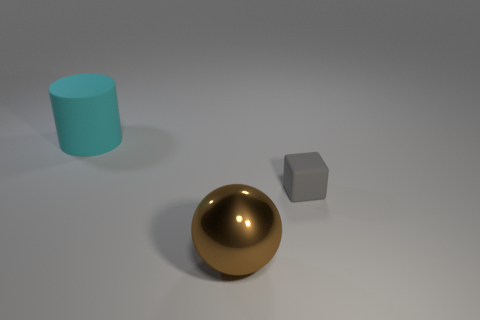There is a large metallic thing; are there any brown objects behind it?
Ensure brevity in your answer.  No. What is the color of the matte object that is behind the matte object that is on the right side of the large object that is in front of the big rubber cylinder?
Your answer should be compact. Cyan. What number of objects are in front of the cylinder and behind the brown ball?
Give a very brief answer. 1. How many spheres are small gray objects or cyan objects?
Make the answer very short. 0. Are there any metal objects?
Your answer should be very brief. Yes. What number of other objects are the same material as the gray block?
Offer a very short reply. 1. There is a brown object that is the same size as the cyan matte object; what is its material?
Keep it short and to the point. Metal. There is a thing that is in front of the small gray rubber block; is its shape the same as the large cyan matte thing?
Your response must be concise. No. Is the color of the shiny sphere the same as the large matte object?
Make the answer very short. No. How many objects are either objects that are in front of the small gray rubber cube or tiny gray cylinders?
Ensure brevity in your answer.  1. 